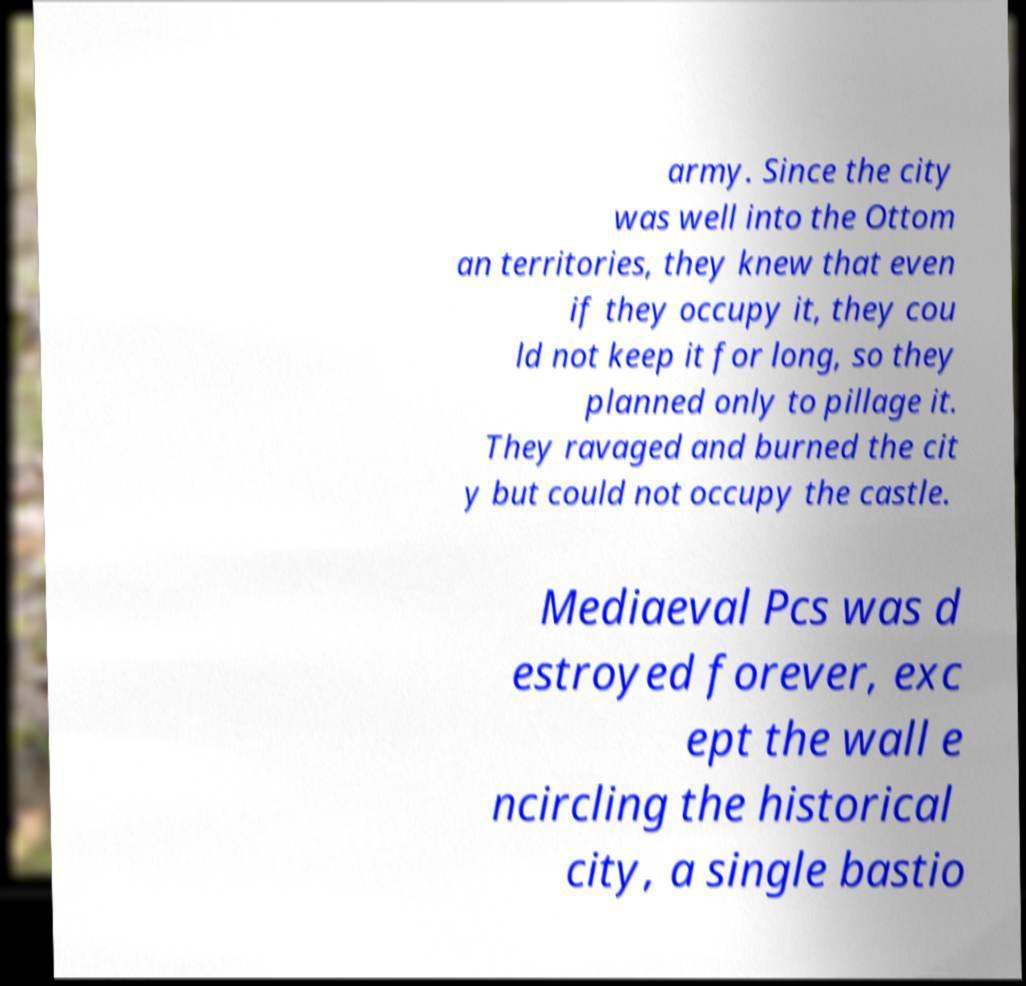Can you accurately transcribe the text from the provided image for me? army. Since the city was well into the Ottom an territories, they knew that even if they occupy it, they cou ld not keep it for long, so they planned only to pillage it. They ravaged and burned the cit y but could not occupy the castle. Mediaeval Pcs was d estroyed forever, exc ept the wall e ncircling the historical city, a single bastio 